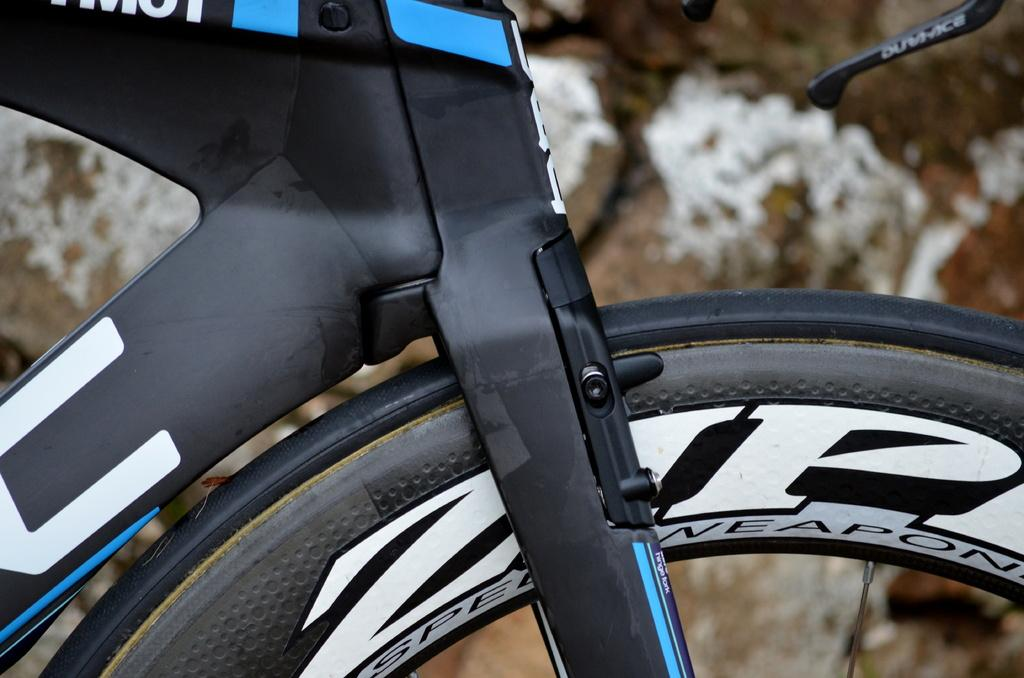What is the main subject of the picture? The main subject of the picture is a bicycle. Can you describe the colors of the bicycle? The bicycle is black, white, and blue in color. Is there any text present on the bicycle? Yes, there is text on the bicycle. What type of cast can be seen on the bicycle in the image? There is no cast present on the bicycle in the image. What kind of board is attached to the bicycle for performing tricks? There is no board attached to the bicycle for performing tricks in the image. 